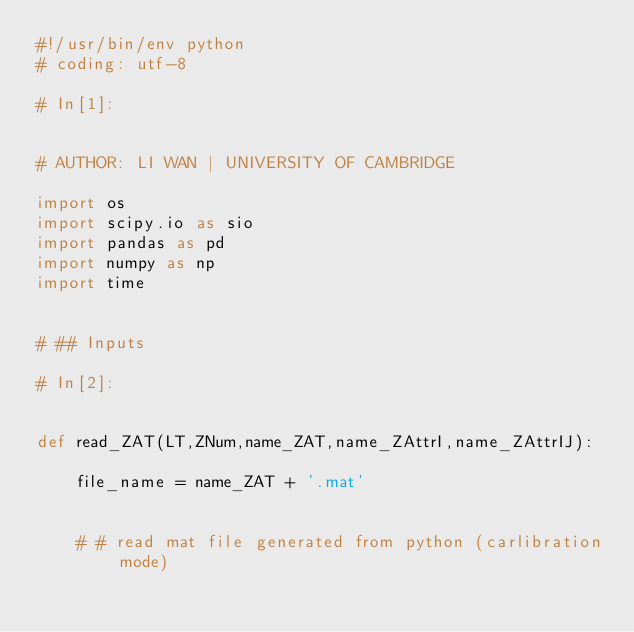<code> <loc_0><loc_0><loc_500><loc_500><_Python_>#!/usr/bin/env python
# coding: utf-8

# In[1]:


# AUTHOR: LI WAN | UNIVERSITY OF CAMBRIDGE

import os
import scipy.io as sio
import pandas as pd
import numpy as np
import time


# ## Inputs

# In[2]:


def read_ZAT(LT,ZNum,name_ZAT,name_ZAttrI,name_ZAttrIJ):
    
    file_name = name_ZAT + '.mat'
    
    
    # # read mat file generated from python (carlibration mode)</code> 